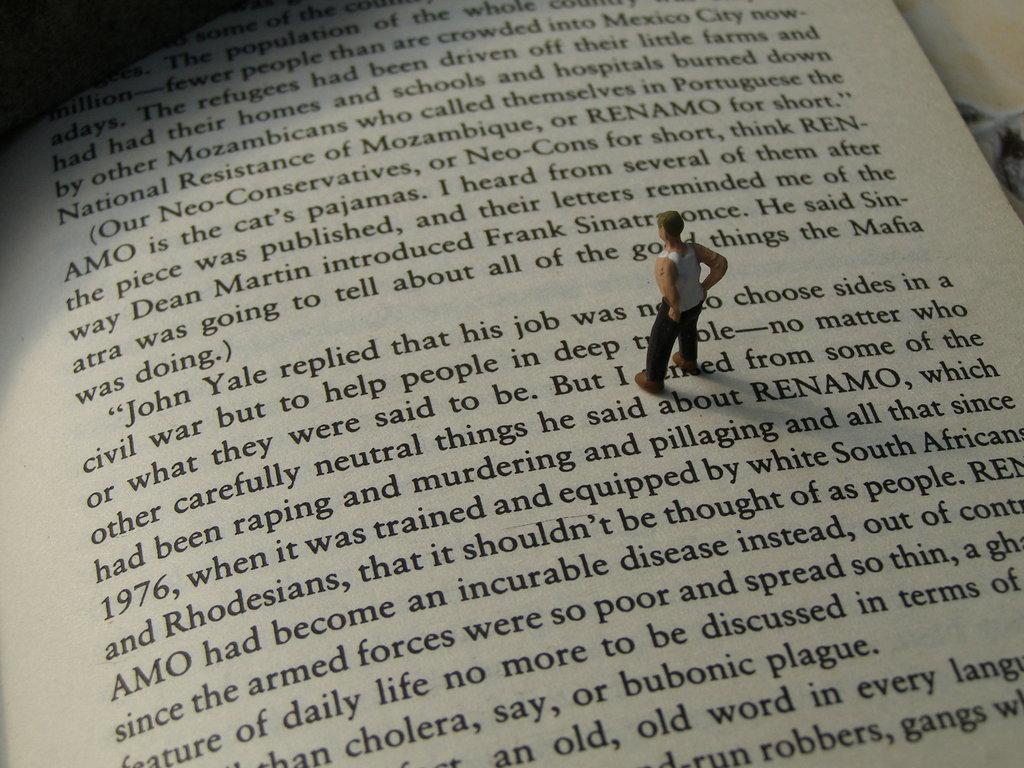<image>
Offer a succinct explanation of the picture presented. a book page that says 'john yale replied that his job was not to choose sides' on it 